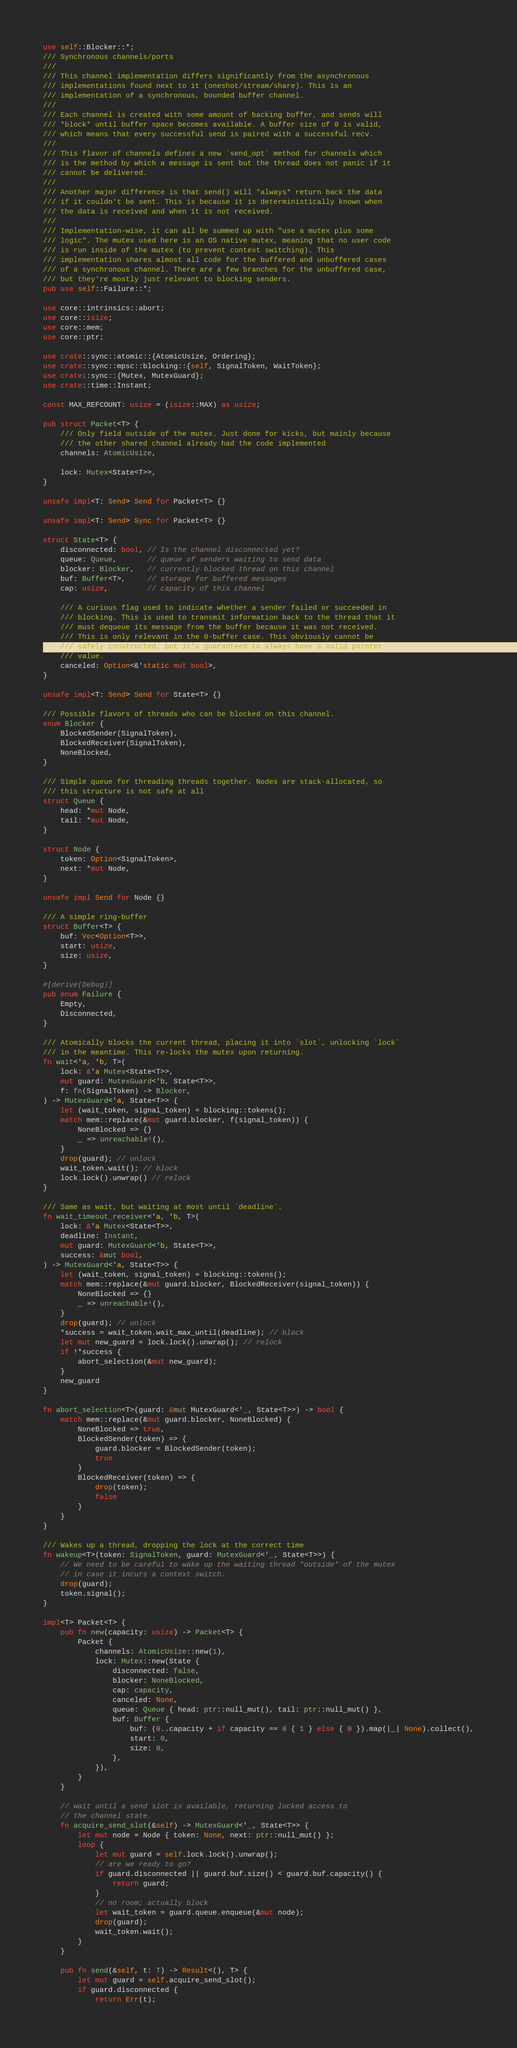Convert code to text. <code><loc_0><loc_0><loc_500><loc_500><_Rust_>use self::Blocker::*;
/// Synchronous channels/ports
///
/// This channel implementation differs significantly from the asynchronous
/// implementations found next to it (oneshot/stream/share). This is an
/// implementation of a synchronous, bounded buffer channel.
///
/// Each channel is created with some amount of backing buffer, and sends will
/// *block* until buffer space becomes available. A buffer size of 0 is valid,
/// which means that every successful send is paired with a successful recv.
///
/// This flavor of channels defines a new `send_opt` method for channels which
/// is the method by which a message is sent but the thread does not panic if it
/// cannot be delivered.
///
/// Another major difference is that send() will *always* return back the data
/// if it couldn't be sent. This is because it is deterministically known when
/// the data is received and when it is not received.
///
/// Implementation-wise, it can all be summed up with "use a mutex plus some
/// logic". The mutex used here is an OS native mutex, meaning that no user code
/// is run inside of the mutex (to prevent context switching). This
/// implementation shares almost all code for the buffered and unbuffered cases
/// of a synchronous channel. There are a few branches for the unbuffered case,
/// but they're mostly just relevant to blocking senders.
pub use self::Failure::*;

use core::intrinsics::abort;
use core::isize;
use core::mem;
use core::ptr;

use crate::sync::atomic::{AtomicUsize, Ordering};
use crate::sync::mpsc::blocking::{self, SignalToken, WaitToken};
use crate::sync::{Mutex, MutexGuard};
use crate::time::Instant;

const MAX_REFCOUNT: usize = (isize::MAX) as usize;

pub struct Packet<T> {
    /// Only field outside of the mutex. Just done for kicks, but mainly because
    /// the other shared channel already had the code implemented
    channels: AtomicUsize,

    lock: Mutex<State<T>>,
}

unsafe impl<T: Send> Send for Packet<T> {}

unsafe impl<T: Send> Sync for Packet<T> {}

struct State<T> {
    disconnected: bool, // Is the channel disconnected yet?
    queue: Queue,       // queue of senders waiting to send data
    blocker: Blocker,   // currently blocked thread on this channel
    buf: Buffer<T>,     // storage for buffered messages
    cap: usize,         // capacity of this channel

    /// A curious flag used to indicate whether a sender failed or succeeded in
    /// blocking. This is used to transmit information back to the thread that it
    /// must dequeue its message from the buffer because it was not received.
    /// This is only relevant in the 0-buffer case. This obviously cannot be
    /// safely constructed, but it's guaranteed to always have a valid pointer
    /// value.
    canceled: Option<&'static mut bool>,
}

unsafe impl<T: Send> Send for State<T> {}

/// Possible flavors of threads who can be blocked on this channel.
enum Blocker {
    BlockedSender(SignalToken),
    BlockedReceiver(SignalToken),
    NoneBlocked,
}

/// Simple queue for threading threads together. Nodes are stack-allocated, so
/// this structure is not safe at all
struct Queue {
    head: *mut Node,
    tail: *mut Node,
}

struct Node {
    token: Option<SignalToken>,
    next: *mut Node,
}

unsafe impl Send for Node {}

/// A simple ring-buffer
struct Buffer<T> {
    buf: Vec<Option<T>>,
    start: usize,
    size: usize,
}

#[derive(Debug)]
pub enum Failure {
    Empty,
    Disconnected,
}

/// Atomically blocks the current thread, placing it into `slot`, unlocking `lock`
/// in the meantime. This re-locks the mutex upon returning.
fn wait<'a, 'b, T>(
    lock: &'a Mutex<State<T>>,
    mut guard: MutexGuard<'b, State<T>>,
    f: fn(SignalToken) -> Blocker,
) -> MutexGuard<'a, State<T>> {
    let (wait_token, signal_token) = blocking::tokens();
    match mem::replace(&mut guard.blocker, f(signal_token)) {
        NoneBlocked => {}
        _ => unreachable!(),
    }
    drop(guard); // unlock
    wait_token.wait(); // block
    lock.lock().unwrap() // relock
}

/// Same as wait, but waiting at most until `deadline`.
fn wait_timeout_receiver<'a, 'b, T>(
    lock: &'a Mutex<State<T>>,
    deadline: Instant,
    mut guard: MutexGuard<'b, State<T>>,
    success: &mut bool,
) -> MutexGuard<'a, State<T>> {
    let (wait_token, signal_token) = blocking::tokens();
    match mem::replace(&mut guard.blocker, BlockedReceiver(signal_token)) {
        NoneBlocked => {}
        _ => unreachable!(),
    }
    drop(guard); // unlock
    *success = wait_token.wait_max_until(deadline); // block
    let mut new_guard = lock.lock().unwrap(); // relock
    if !*success {
        abort_selection(&mut new_guard);
    }
    new_guard
}

fn abort_selection<T>(guard: &mut MutexGuard<'_, State<T>>) -> bool {
    match mem::replace(&mut guard.blocker, NoneBlocked) {
        NoneBlocked => true,
        BlockedSender(token) => {
            guard.blocker = BlockedSender(token);
            true
        }
        BlockedReceiver(token) => {
            drop(token);
            false
        }
    }
}

/// Wakes up a thread, dropping the lock at the correct time
fn wakeup<T>(token: SignalToken, guard: MutexGuard<'_, State<T>>) {
    // We need to be careful to wake up the waiting thread *outside* of the mutex
    // in case it incurs a context switch.
    drop(guard);
    token.signal();
}

impl<T> Packet<T> {
    pub fn new(capacity: usize) -> Packet<T> {
        Packet {
            channels: AtomicUsize::new(1),
            lock: Mutex::new(State {
                disconnected: false,
                blocker: NoneBlocked,
                cap: capacity,
                canceled: None,
                queue: Queue { head: ptr::null_mut(), tail: ptr::null_mut() },
                buf: Buffer {
                    buf: (0..capacity + if capacity == 0 { 1 } else { 0 }).map(|_| None).collect(),
                    start: 0,
                    size: 0,
                },
            }),
        }
    }

    // wait until a send slot is available, returning locked access to
    // the channel state.
    fn acquire_send_slot(&self) -> MutexGuard<'_, State<T>> {
        let mut node = Node { token: None, next: ptr::null_mut() };
        loop {
            let mut guard = self.lock.lock().unwrap();
            // are we ready to go?
            if guard.disconnected || guard.buf.size() < guard.buf.capacity() {
                return guard;
            }
            // no room; actually block
            let wait_token = guard.queue.enqueue(&mut node);
            drop(guard);
            wait_token.wait();
        }
    }

    pub fn send(&self, t: T) -> Result<(), T> {
        let mut guard = self.acquire_send_slot();
        if guard.disconnected {
            return Err(t);</code> 